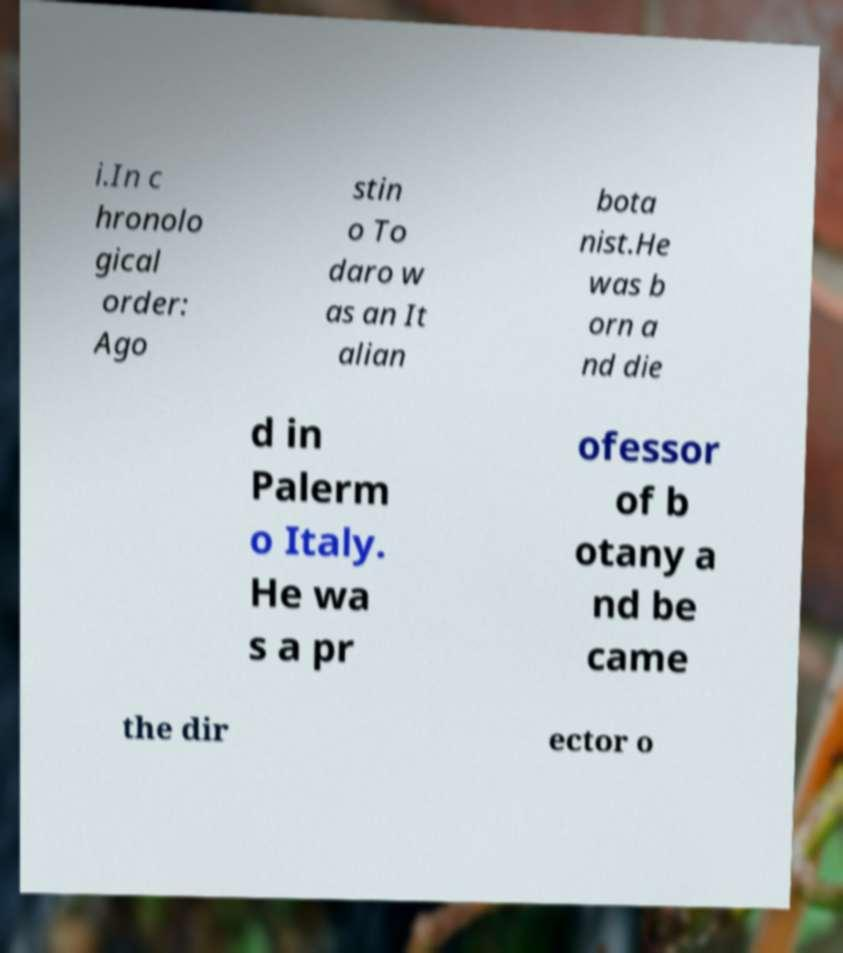Please identify and transcribe the text found in this image. i.In c hronolo gical order: Ago stin o To daro w as an It alian bota nist.He was b orn a nd die d in Palerm o Italy. He wa s a pr ofessor of b otany a nd be came the dir ector o 